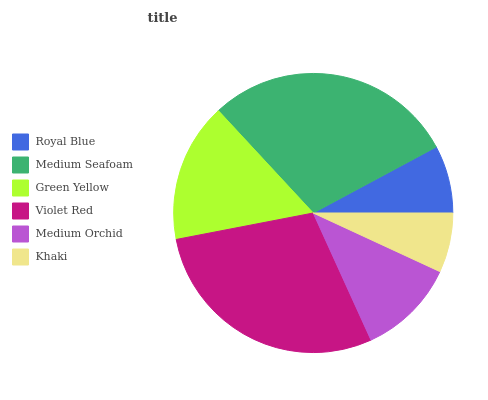Is Khaki the minimum?
Answer yes or no. Yes. Is Medium Seafoam the maximum?
Answer yes or no. Yes. Is Green Yellow the minimum?
Answer yes or no. No. Is Green Yellow the maximum?
Answer yes or no. No. Is Medium Seafoam greater than Green Yellow?
Answer yes or no. Yes. Is Green Yellow less than Medium Seafoam?
Answer yes or no. Yes. Is Green Yellow greater than Medium Seafoam?
Answer yes or no. No. Is Medium Seafoam less than Green Yellow?
Answer yes or no. No. Is Green Yellow the high median?
Answer yes or no. Yes. Is Medium Orchid the low median?
Answer yes or no. Yes. Is Khaki the high median?
Answer yes or no. No. Is Royal Blue the low median?
Answer yes or no. No. 